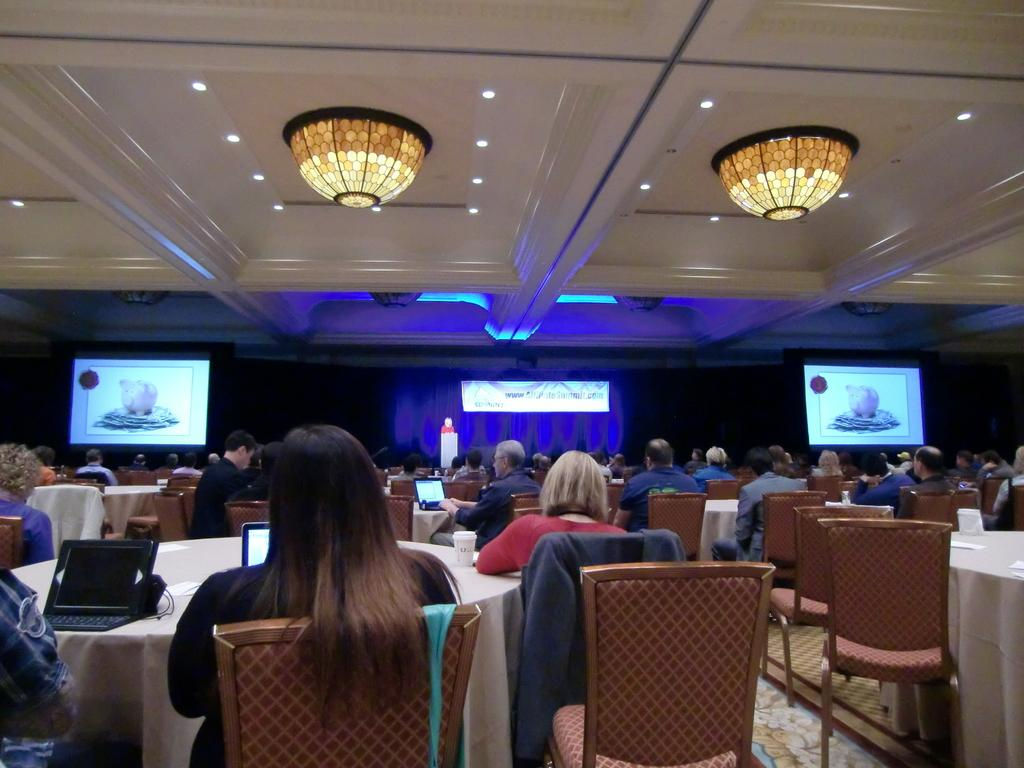How many people are in the image? There is a group of people in the image, but the exact number is not specified. What are the people doing in the image? The people are sitting on chairs in the image. What is on the tables in the image? Laptops and glasses are present on the tables in the image. What can be seen in the background of the image? Screens, the ceiling, and other objects can be seen in the background of the image. What type of stomach ache is the person experiencing in the image? There is no indication of anyone experiencing a stomach ache in the image. Can you tell me how many tanks are visible in the image? There are no tanks present in the image. Are there any boats visible in the image? There are no boats present in the image. 